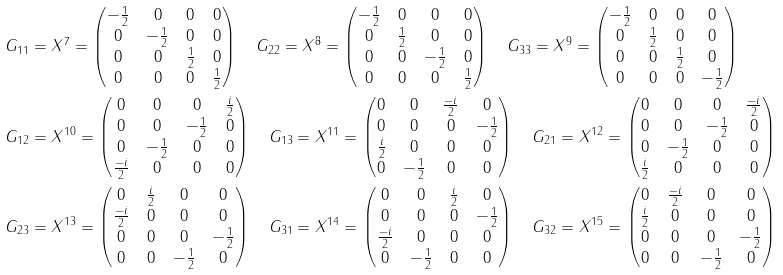<formula> <loc_0><loc_0><loc_500><loc_500>& G _ { 1 1 } = X ^ { 7 } = \begin{pmatrix} - \frac { 1 } { 2 } & 0 & 0 & 0 \\ 0 & - \frac { 1 } { 2 } & 0 & 0 \\ 0 & 0 & \frac { 1 } { 2 } & 0 \\ 0 & 0 & 0 & \frac { 1 } { 2 } \end{pmatrix} \quad G _ { 2 2 } = X ^ { 8 } = \begin{pmatrix} - \frac { 1 } { 2 } & 0 & 0 & 0 \\ 0 & \frac { 1 } { 2 } & 0 & 0 \\ 0 & 0 & - \frac { 1 } { 2 } & 0 \\ 0 & 0 & 0 & \frac { 1 } { 2 } \end{pmatrix} \quad G _ { 3 3 } = X ^ { 9 } = \begin{pmatrix} - \frac { 1 } { 2 } & 0 & 0 & 0 \\ 0 & \frac { 1 } { 2 } & 0 & 0 \\ 0 & 0 & \frac { 1 } { 2 } & 0 \\ 0 & 0 & 0 & - \frac { 1 } { 2 } \end{pmatrix} \\ & G _ { 1 2 } = X ^ { 1 0 } = \begin{pmatrix} 0 & 0 & 0 & \frac { i } { 2 } \\ 0 & 0 & - \frac { 1 } { 2 } & 0 \\ 0 & - \frac { 1 } { 2 } & 0 & 0 \\ \frac { - i } { 2 } & 0 & 0 & 0 \end{pmatrix} \quad G _ { 1 3 } = X ^ { 1 1 } = \begin{pmatrix} 0 & 0 & \frac { - i } { 2 } & 0 \\ 0 & 0 & 0 & - \frac { 1 } { 2 } \\ \frac { i } { 2 } & 0 & 0 & 0 \\ 0 & - \frac { 1 } { 2 } & 0 & 0 \end{pmatrix} \quad G _ { 2 1 } = X ^ { 1 2 } = \begin{pmatrix} 0 & 0 & 0 & \frac { - i } { 2 } \\ 0 & 0 & - \frac { 1 } { 2 } & 0 \\ 0 & - \frac { 1 } { 2 } & 0 & 0 \\ \frac { i } { 2 } & 0 & 0 & 0 \end{pmatrix} \\ & G _ { 2 3 } = X ^ { 1 3 } = \begin{pmatrix} 0 & \frac { i } { 2 } & 0 & 0 \\ \frac { - i } { 2 } & 0 & 0 & 0 \\ 0 & 0 & 0 & - \frac { 1 } { 2 } \\ 0 & 0 & - \frac { 1 } { 2 } & 0 \end{pmatrix} \quad G _ { 3 1 } = X ^ { 1 4 } = \begin{pmatrix} 0 & 0 & \frac { i } { 2 } & 0 \\ 0 & 0 & 0 & - \frac { 1 } { 2 } \\ \frac { - i } { 2 } & 0 & 0 & 0 \\ 0 & - \frac { 1 } { 2 } & 0 & 0 \end{pmatrix} \quad G _ { 3 2 } = X ^ { 1 5 } = \begin{pmatrix} 0 & \frac { - i } { 2 } & 0 & 0 \\ \frac { i } { 2 } & 0 & 0 & 0 \\ 0 & 0 & 0 & - \frac { 1 } { 2 } \\ 0 & 0 & - \frac { 1 } { 2 } & 0 \end{pmatrix}</formula> 